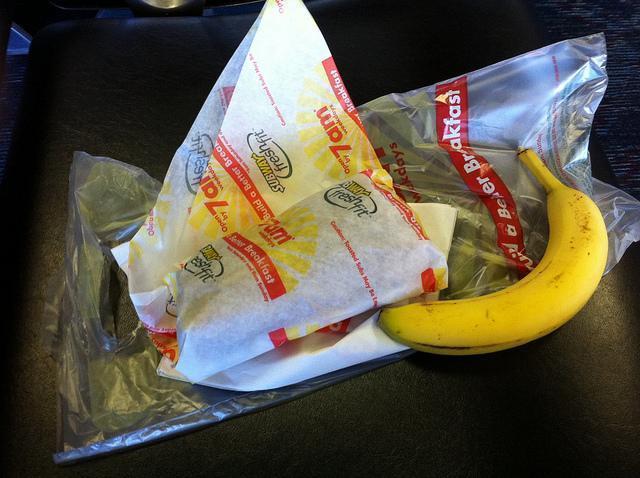How many people in this image are wearing hats?
Give a very brief answer. 0. 